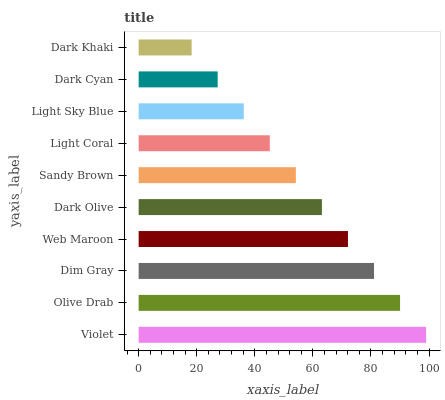Is Dark Khaki the minimum?
Answer yes or no. Yes. Is Violet the maximum?
Answer yes or no. Yes. Is Olive Drab the minimum?
Answer yes or no. No. Is Olive Drab the maximum?
Answer yes or no. No. Is Violet greater than Olive Drab?
Answer yes or no. Yes. Is Olive Drab less than Violet?
Answer yes or no. Yes. Is Olive Drab greater than Violet?
Answer yes or no. No. Is Violet less than Olive Drab?
Answer yes or no. No. Is Dark Olive the high median?
Answer yes or no. Yes. Is Sandy Brown the low median?
Answer yes or no. Yes. Is Dark Cyan the high median?
Answer yes or no. No. Is Violet the low median?
Answer yes or no. No. 